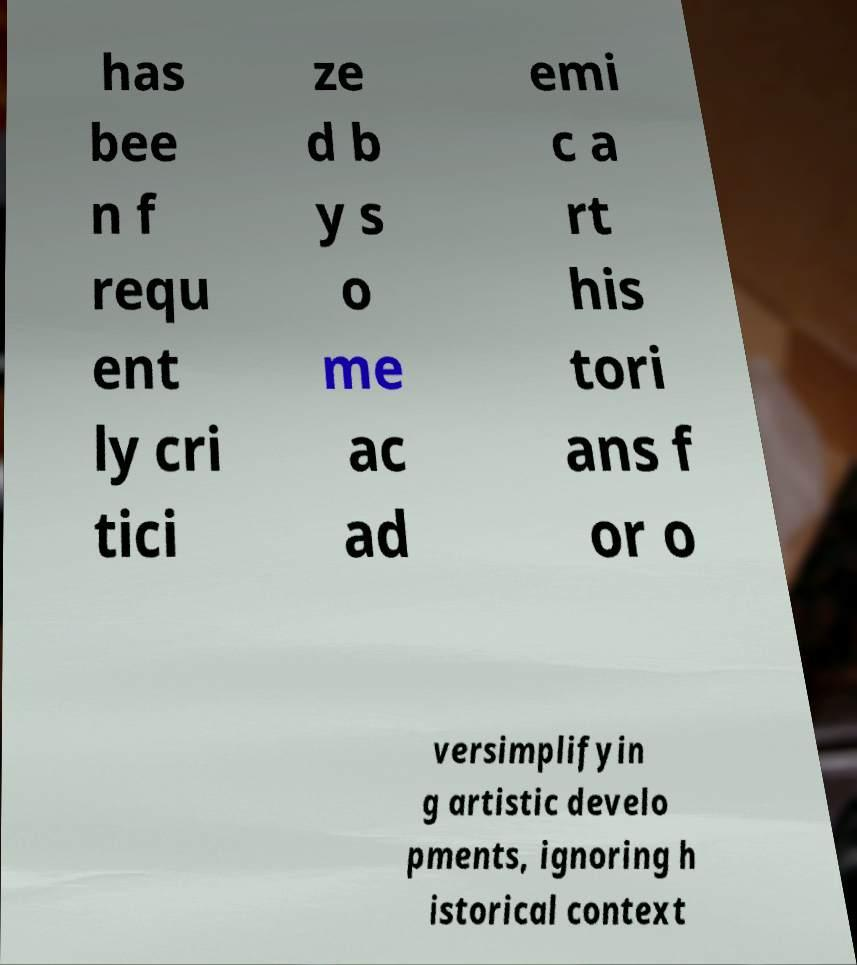What messages or text are displayed in this image? I need them in a readable, typed format. has bee n f requ ent ly cri tici ze d b y s o me ac ad emi c a rt his tori ans f or o versimplifyin g artistic develo pments, ignoring h istorical context 